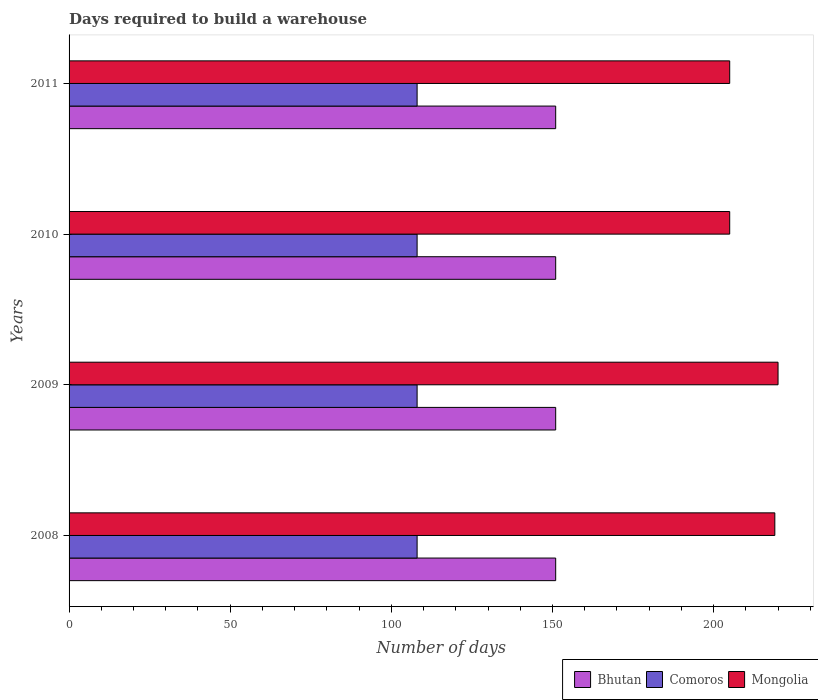How many groups of bars are there?
Give a very brief answer. 4. Are the number of bars on each tick of the Y-axis equal?
Make the answer very short. Yes. What is the days required to build a warehouse in in Bhutan in 2009?
Your answer should be very brief. 151. Across all years, what is the maximum days required to build a warehouse in in Bhutan?
Keep it short and to the point. 151. Across all years, what is the minimum days required to build a warehouse in in Bhutan?
Offer a terse response. 151. What is the total days required to build a warehouse in in Mongolia in the graph?
Your response must be concise. 849. What is the difference between the days required to build a warehouse in in Bhutan in 2010 and the days required to build a warehouse in in Comoros in 2009?
Offer a very short reply. 43. What is the average days required to build a warehouse in in Comoros per year?
Provide a succinct answer. 108. In the year 2008, what is the difference between the days required to build a warehouse in in Comoros and days required to build a warehouse in in Bhutan?
Give a very brief answer. -43. What is the ratio of the days required to build a warehouse in in Mongolia in 2008 to that in 2011?
Offer a terse response. 1.07. What does the 2nd bar from the top in 2011 represents?
Give a very brief answer. Comoros. What does the 1st bar from the bottom in 2010 represents?
Provide a short and direct response. Bhutan. How many years are there in the graph?
Provide a short and direct response. 4. What is the difference between two consecutive major ticks on the X-axis?
Your answer should be compact. 50. Are the values on the major ticks of X-axis written in scientific E-notation?
Keep it short and to the point. No. How many legend labels are there?
Your answer should be compact. 3. How are the legend labels stacked?
Provide a short and direct response. Horizontal. What is the title of the graph?
Offer a very short reply. Days required to build a warehouse. What is the label or title of the X-axis?
Provide a succinct answer. Number of days. What is the Number of days of Bhutan in 2008?
Provide a short and direct response. 151. What is the Number of days in Comoros in 2008?
Your answer should be compact. 108. What is the Number of days of Mongolia in 2008?
Make the answer very short. 219. What is the Number of days of Bhutan in 2009?
Keep it short and to the point. 151. What is the Number of days of Comoros in 2009?
Provide a short and direct response. 108. What is the Number of days of Mongolia in 2009?
Offer a terse response. 220. What is the Number of days of Bhutan in 2010?
Your answer should be very brief. 151. What is the Number of days in Comoros in 2010?
Offer a very short reply. 108. What is the Number of days of Mongolia in 2010?
Offer a terse response. 205. What is the Number of days in Bhutan in 2011?
Your answer should be very brief. 151. What is the Number of days of Comoros in 2011?
Keep it short and to the point. 108. What is the Number of days of Mongolia in 2011?
Offer a terse response. 205. Across all years, what is the maximum Number of days of Bhutan?
Ensure brevity in your answer.  151. Across all years, what is the maximum Number of days in Comoros?
Give a very brief answer. 108. Across all years, what is the maximum Number of days of Mongolia?
Your response must be concise. 220. Across all years, what is the minimum Number of days in Bhutan?
Provide a succinct answer. 151. Across all years, what is the minimum Number of days of Comoros?
Keep it short and to the point. 108. Across all years, what is the minimum Number of days in Mongolia?
Give a very brief answer. 205. What is the total Number of days of Bhutan in the graph?
Give a very brief answer. 604. What is the total Number of days in Comoros in the graph?
Offer a terse response. 432. What is the total Number of days in Mongolia in the graph?
Keep it short and to the point. 849. What is the difference between the Number of days in Comoros in 2008 and that in 2009?
Give a very brief answer. 0. What is the difference between the Number of days in Comoros in 2008 and that in 2010?
Offer a very short reply. 0. What is the difference between the Number of days of Mongolia in 2008 and that in 2010?
Give a very brief answer. 14. What is the difference between the Number of days of Comoros in 2009 and that in 2010?
Provide a short and direct response. 0. What is the difference between the Number of days of Bhutan in 2009 and that in 2011?
Offer a terse response. 0. What is the difference between the Number of days of Comoros in 2010 and that in 2011?
Offer a terse response. 0. What is the difference between the Number of days in Bhutan in 2008 and the Number of days in Comoros in 2009?
Offer a very short reply. 43. What is the difference between the Number of days of Bhutan in 2008 and the Number of days of Mongolia in 2009?
Give a very brief answer. -69. What is the difference between the Number of days of Comoros in 2008 and the Number of days of Mongolia in 2009?
Your answer should be very brief. -112. What is the difference between the Number of days in Bhutan in 2008 and the Number of days in Comoros in 2010?
Give a very brief answer. 43. What is the difference between the Number of days of Bhutan in 2008 and the Number of days of Mongolia in 2010?
Provide a short and direct response. -54. What is the difference between the Number of days in Comoros in 2008 and the Number of days in Mongolia in 2010?
Make the answer very short. -97. What is the difference between the Number of days of Bhutan in 2008 and the Number of days of Comoros in 2011?
Make the answer very short. 43. What is the difference between the Number of days in Bhutan in 2008 and the Number of days in Mongolia in 2011?
Provide a short and direct response. -54. What is the difference between the Number of days in Comoros in 2008 and the Number of days in Mongolia in 2011?
Give a very brief answer. -97. What is the difference between the Number of days in Bhutan in 2009 and the Number of days in Mongolia in 2010?
Your response must be concise. -54. What is the difference between the Number of days in Comoros in 2009 and the Number of days in Mongolia in 2010?
Your answer should be compact. -97. What is the difference between the Number of days in Bhutan in 2009 and the Number of days in Comoros in 2011?
Provide a succinct answer. 43. What is the difference between the Number of days of Bhutan in 2009 and the Number of days of Mongolia in 2011?
Your response must be concise. -54. What is the difference between the Number of days of Comoros in 2009 and the Number of days of Mongolia in 2011?
Provide a succinct answer. -97. What is the difference between the Number of days of Bhutan in 2010 and the Number of days of Comoros in 2011?
Your response must be concise. 43. What is the difference between the Number of days of Bhutan in 2010 and the Number of days of Mongolia in 2011?
Provide a succinct answer. -54. What is the difference between the Number of days of Comoros in 2010 and the Number of days of Mongolia in 2011?
Offer a very short reply. -97. What is the average Number of days in Bhutan per year?
Your answer should be very brief. 151. What is the average Number of days in Comoros per year?
Offer a very short reply. 108. What is the average Number of days in Mongolia per year?
Ensure brevity in your answer.  212.25. In the year 2008, what is the difference between the Number of days in Bhutan and Number of days in Comoros?
Provide a succinct answer. 43. In the year 2008, what is the difference between the Number of days in Bhutan and Number of days in Mongolia?
Make the answer very short. -68. In the year 2008, what is the difference between the Number of days in Comoros and Number of days in Mongolia?
Provide a succinct answer. -111. In the year 2009, what is the difference between the Number of days of Bhutan and Number of days of Mongolia?
Offer a very short reply. -69. In the year 2009, what is the difference between the Number of days in Comoros and Number of days in Mongolia?
Your response must be concise. -112. In the year 2010, what is the difference between the Number of days in Bhutan and Number of days in Comoros?
Your answer should be compact. 43. In the year 2010, what is the difference between the Number of days of Bhutan and Number of days of Mongolia?
Make the answer very short. -54. In the year 2010, what is the difference between the Number of days in Comoros and Number of days in Mongolia?
Keep it short and to the point. -97. In the year 2011, what is the difference between the Number of days of Bhutan and Number of days of Mongolia?
Ensure brevity in your answer.  -54. In the year 2011, what is the difference between the Number of days in Comoros and Number of days in Mongolia?
Ensure brevity in your answer.  -97. What is the ratio of the Number of days of Comoros in 2008 to that in 2009?
Ensure brevity in your answer.  1. What is the ratio of the Number of days in Mongolia in 2008 to that in 2009?
Keep it short and to the point. 1. What is the ratio of the Number of days in Bhutan in 2008 to that in 2010?
Make the answer very short. 1. What is the ratio of the Number of days of Mongolia in 2008 to that in 2010?
Make the answer very short. 1.07. What is the ratio of the Number of days in Comoros in 2008 to that in 2011?
Make the answer very short. 1. What is the ratio of the Number of days in Mongolia in 2008 to that in 2011?
Your response must be concise. 1.07. What is the ratio of the Number of days in Bhutan in 2009 to that in 2010?
Offer a very short reply. 1. What is the ratio of the Number of days of Comoros in 2009 to that in 2010?
Offer a terse response. 1. What is the ratio of the Number of days in Mongolia in 2009 to that in 2010?
Keep it short and to the point. 1.07. What is the ratio of the Number of days of Bhutan in 2009 to that in 2011?
Keep it short and to the point. 1. What is the ratio of the Number of days in Comoros in 2009 to that in 2011?
Give a very brief answer. 1. What is the ratio of the Number of days in Mongolia in 2009 to that in 2011?
Provide a succinct answer. 1.07. What is the ratio of the Number of days in Comoros in 2010 to that in 2011?
Your response must be concise. 1. What is the ratio of the Number of days of Mongolia in 2010 to that in 2011?
Your answer should be very brief. 1. What is the difference between the highest and the second highest Number of days in Comoros?
Offer a very short reply. 0. What is the difference between the highest and the lowest Number of days of Bhutan?
Your answer should be compact. 0. What is the difference between the highest and the lowest Number of days of Comoros?
Offer a terse response. 0. 